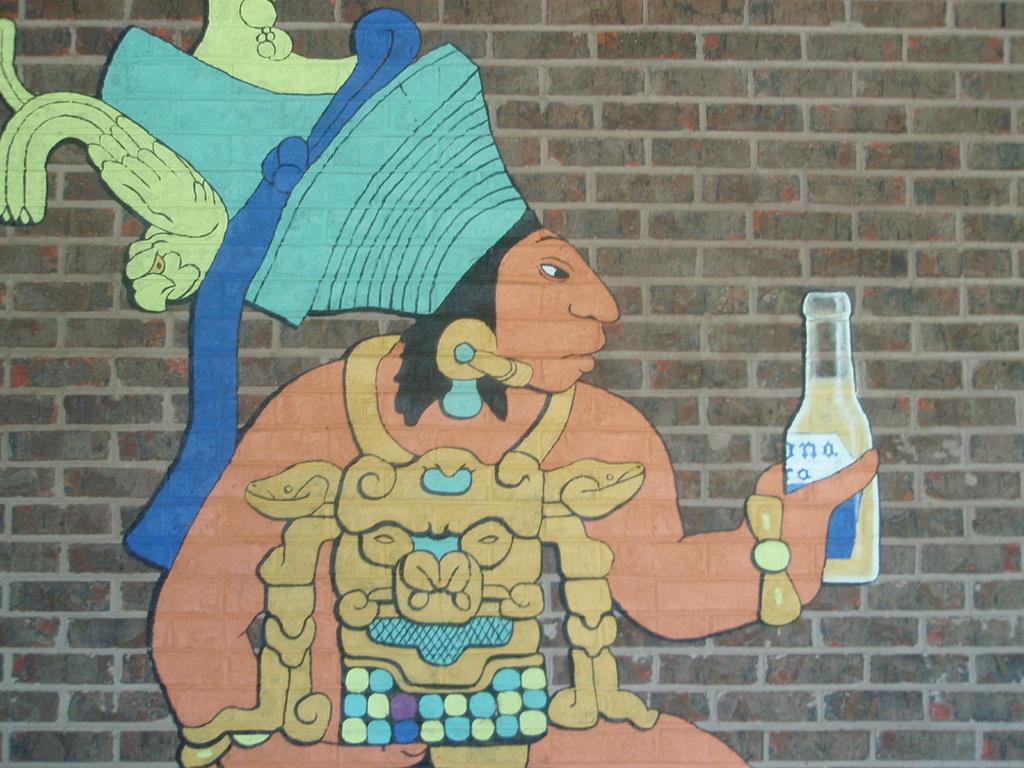What is the name of the drink the man is holding?
Offer a very short reply. Corona. 